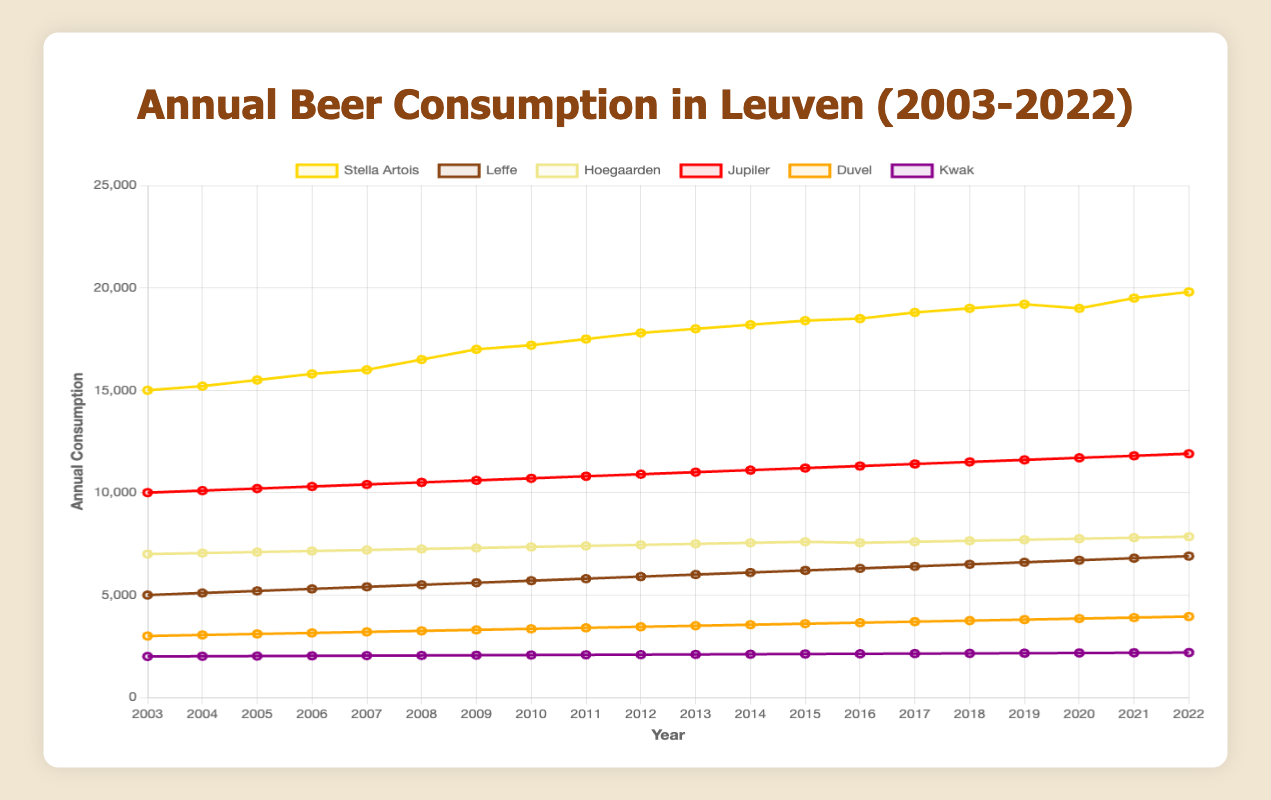What is the total consumption of Stella Artois and Leffe in 2022? To find the total consumption of Stella Artois and Leffe in 2022, sum the values of both beers for that year. From the data, Stella Artois had a consumption of 19800 and Leffe had 6900 in 2022. Therefore, the total consumption is 19800 + 6900 = 26700.
Answer: 26700 Which beer had the highest consumption in the year 2010? Look at the data for the year 2010 for all beer types. Stella Artois had 17200, Leffe had 5700, Hoegaarden had 7350, Jupiler had 10700, Duvel had 3350, and Kwak had 2070. The highest consumption in 2010 was Stella Artois with 17200.
Answer: Stella Artois Did the consumption of Hoegaarden increase, decrease, or remain the same from 2019 to 2020? Compare the values for Hoegaarden in 2019 and 2020. In 2019, the consumption was 7700, and in 2020, it was 7750. Since 7750 is greater than 7700, the consumption increased.
Answer: Increased How much more beer was consumed (in total) of Jupiler than Duvel in 2015? Find the difference in consumption between Jupiler and Duvel in 2015. Jupiler had 11200 and Duvel had 3600. The difference is 11200 - 3600 = 7600.
Answer: 7600 Which beer shows the least overall increase in annual consumption from 2003 to 2022? Calculate the difference in consumption for each beer type between the years 2003 and 2022. The differences are: Stella Artois (19800 - 15000 = 4800), Leffe (6900 - 5000 = 1900), Hoegaarden (7850 - 7000 = 850), Jupiler (11900 - 10000 = 1900), Duvel (3950 - 3000 = 950), and Kwak (2190 - 2000 = 190). Kwak shows the least overall increase with a difference of 190.
Answer: Kwak What is the average annual consumption of Stella Artois over the 20 years? Sum the annual consumption values of Stella Artois from 2003 to 2022 and divide by 20. The sum is 15000 + 15200 + 15500 + 15800 + 16000 + 16500 + 17000 + 17200 + 17500 + 17800 + 18000 + 18200 + 18400 + 18500 + 18800 + 19000 + 19200 + 19000 + 19500 + 19800 = 338400. Divide by 20 to get the average: 338400/20 = 16920.
Answer: 16920 